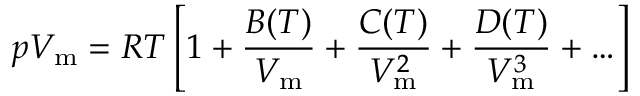Convert formula to latex. <formula><loc_0><loc_0><loc_500><loc_500>p V _ { m } = R T \left [ 1 + { \frac { B ( T ) } { V _ { m } } } + { \frac { C ( T ) } { V _ { m } ^ { 2 } } } + { \frac { D ( T ) } { V _ { m } ^ { 3 } } } + \dots \right ]</formula> 